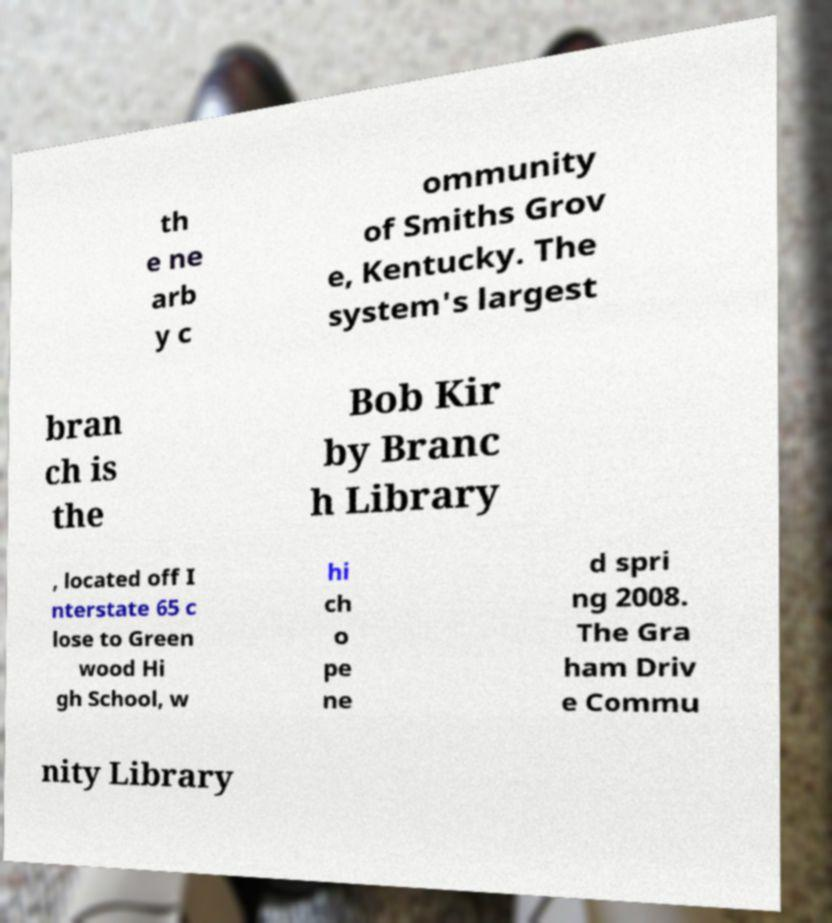For documentation purposes, I need the text within this image transcribed. Could you provide that? th e ne arb y c ommunity of Smiths Grov e, Kentucky. The system's largest bran ch is the Bob Kir by Branc h Library , located off I nterstate 65 c lose to Green wood Hi gh School, w hi ch o pe ne d spri ng 2008. The Gra ham Driv e Commu nity Library 